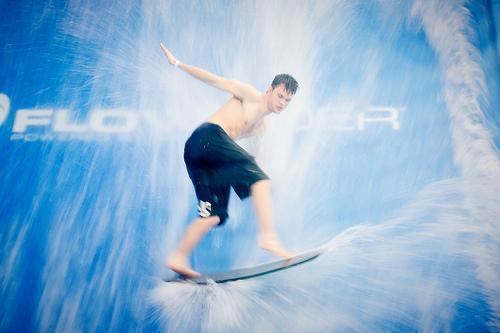How many men are there?
Give a very brief answer. 1. 